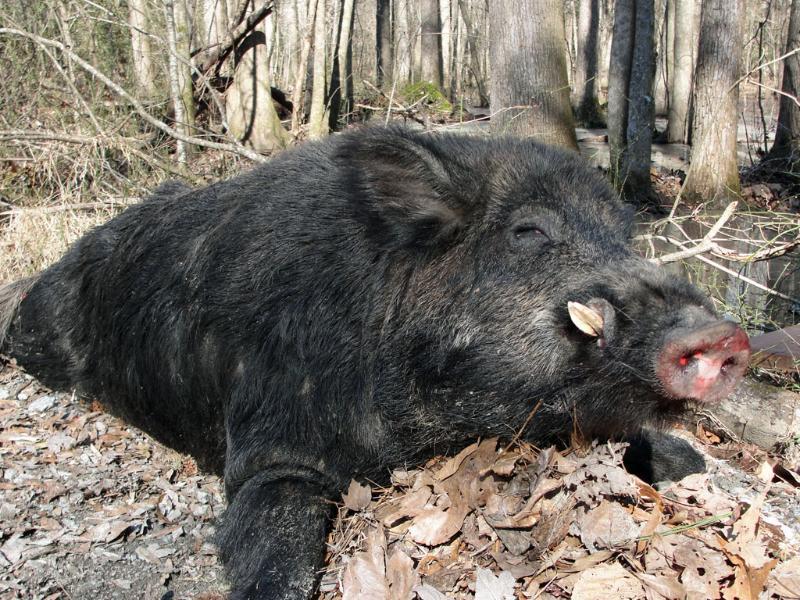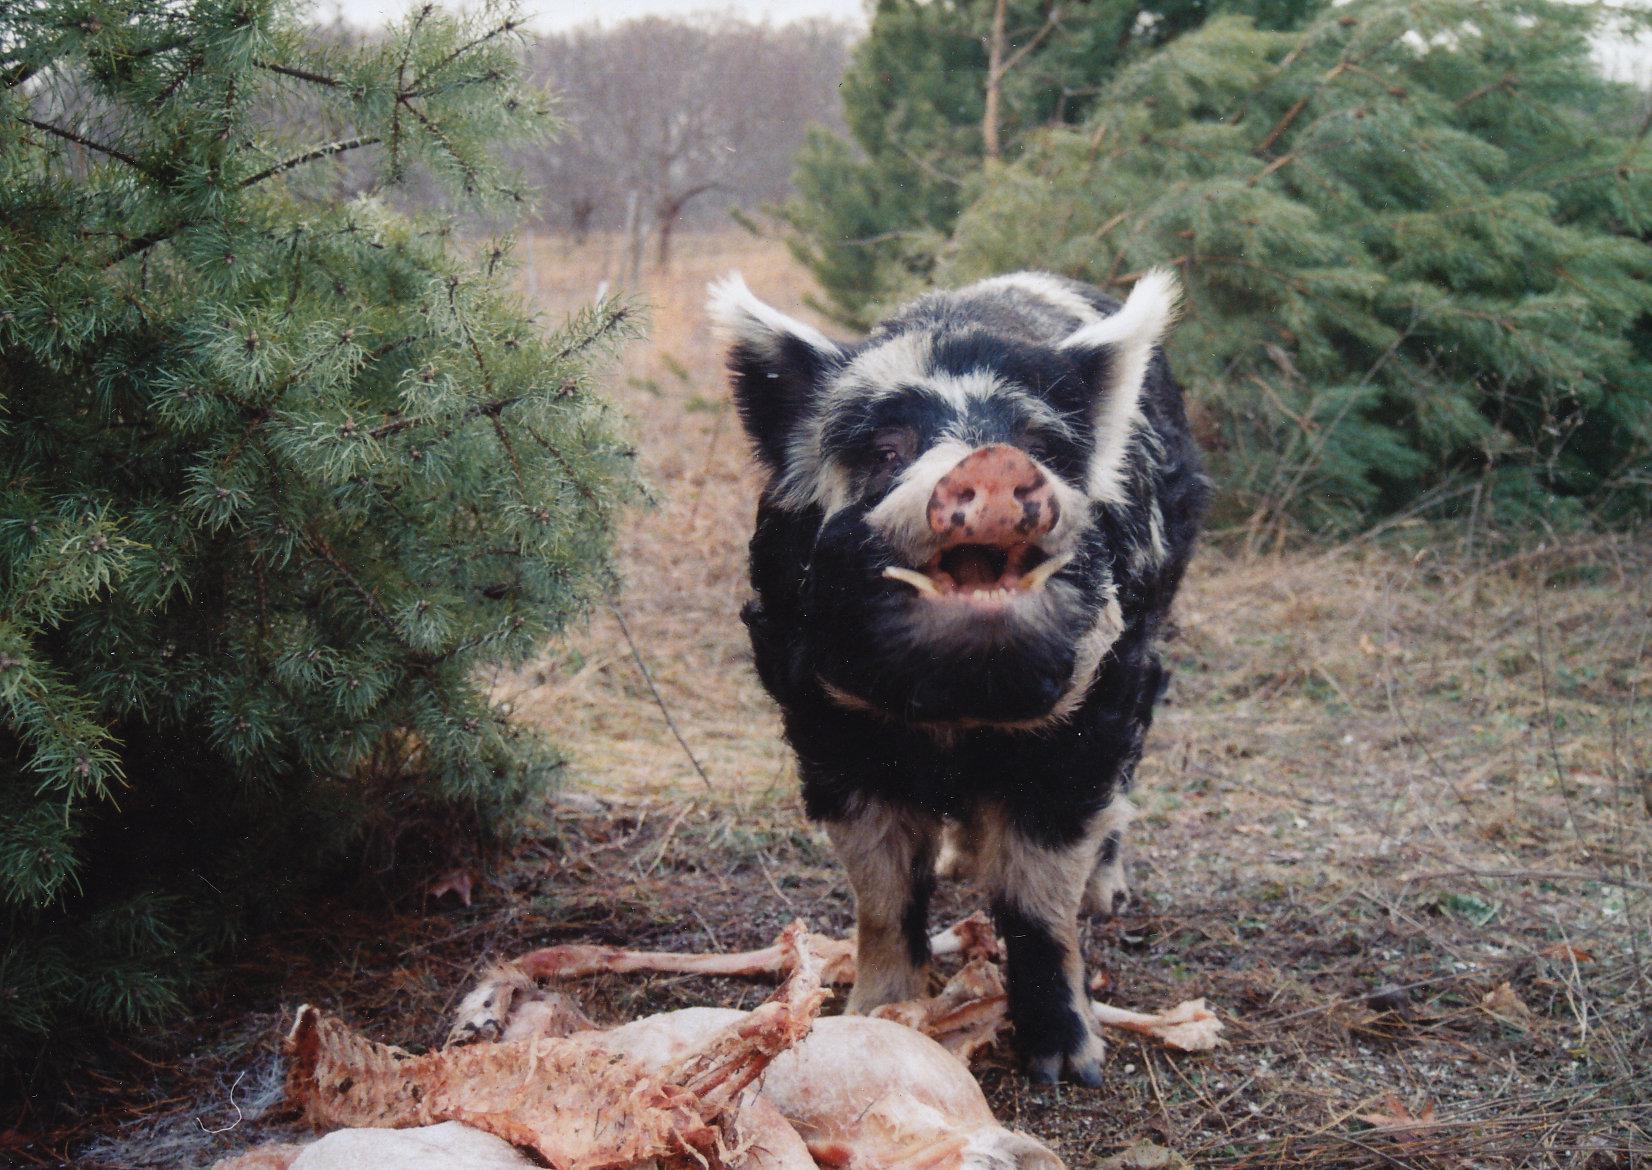The first image is the image on the left, the second image is the image on the right. Given the left and right images, does the statement "In one image there is multiple striped pigs." hold true? Answer yes or no. No. 